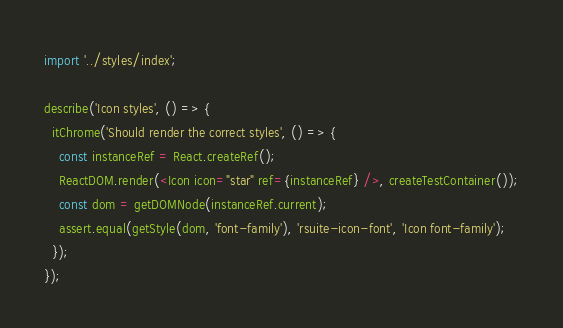Convert code to text. <code><loc_0><loc_0><loc_500><loc_500><_JavaScript_>import '../styles/index';

describe('Icon styles', () => {
  itChrome('Should render the correct styles', () => {
    const instanceRef = React.createRef();
    ReactDOM.render(<Icon icon="star" ref={instanceRef} />, createTestContainer());
    const dom = getDOMNode(instanceRef.current);
    assert.equal(getStyle(dom, 'font-family'), 'rsuite-icon-font', 'Icon font-family');
  });
});
</code> 